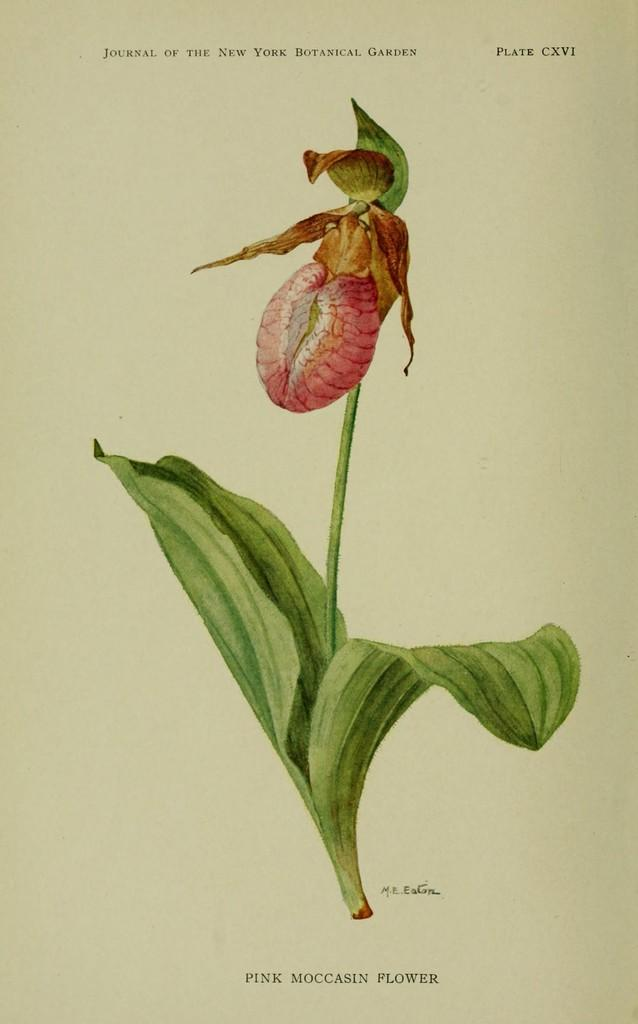What type of flower can be seen in the image? There is a red color flower in the image. What else is present on the paper in the image? There are leaves on the paper in the image. What can be found on the paper besides the leaves? There is writing on the paper in the image. What is the scent of the lake in the image? There is no lake present in the image, so it is not possible to determine its scent. 